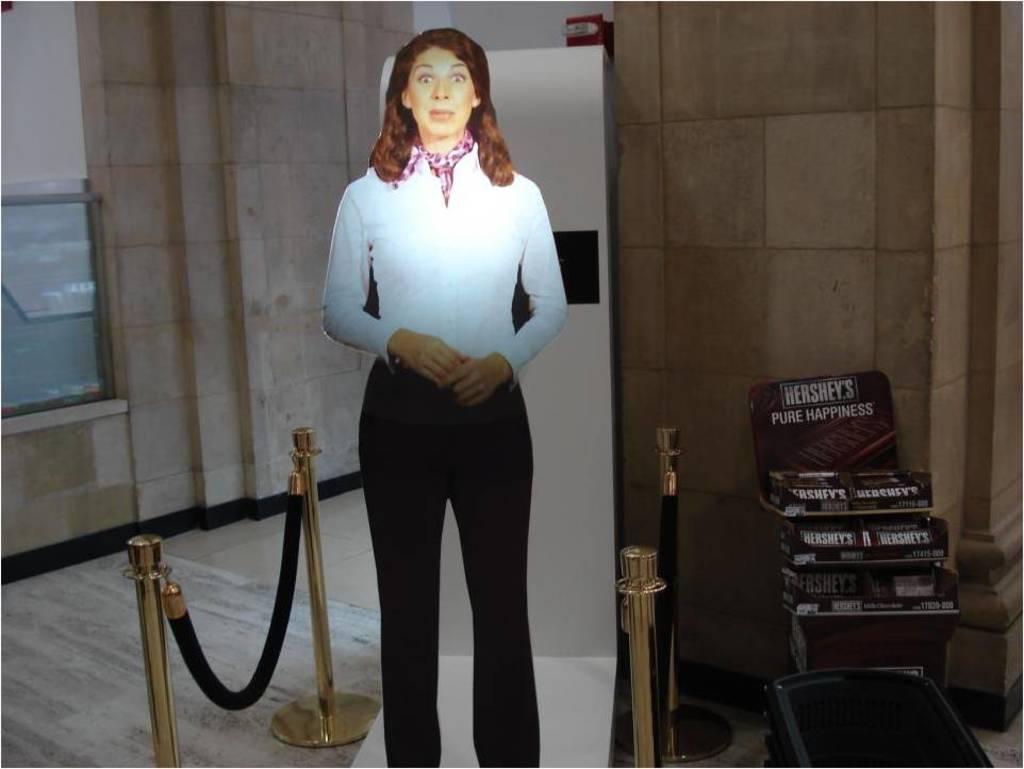What does hershey's promise, according to this display?
Offer a very short reply. Pure happiness. 